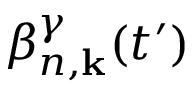<formula> <loc_0><loc_0><loc_500><loc_500>\beta _ { n , k } ^ { \gamma } ( t ^ { \prime } )</formula> 